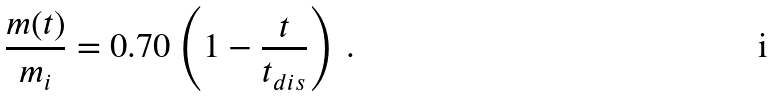Convert formula to latex. <formula><loc_0><loc_0><loc_500><loc_500>\frac { m ( t ) } { m _ { i } } = 0 . 7 0 \left ( 1 - \frac { t } { t _ { d i s } } \right ) \, .</formula> 